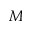<formula> <loc_0><loc_0><loc_500><loc_500>M</formula> 